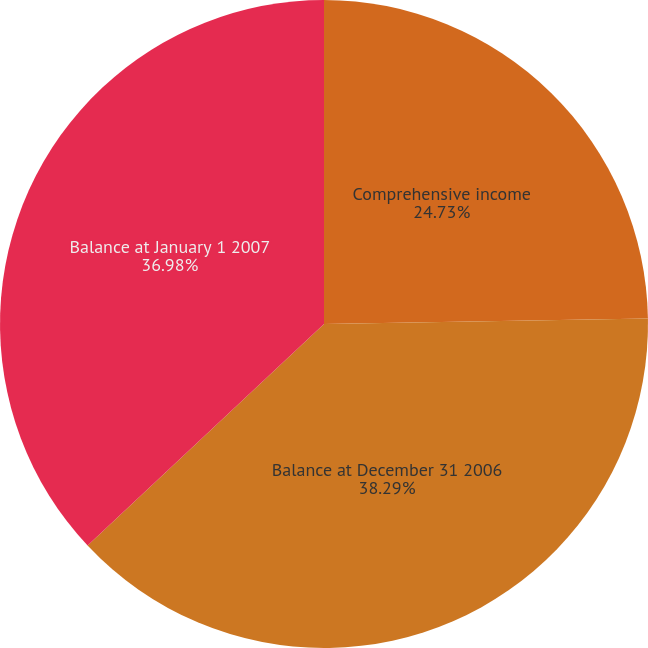Convert chart to OTSL. <chart><loc_0><loc_0><loc_500><loc_500><pie_chart><fcel>Comprehensive income<fcel>Balance at December 31 2006<fcel>Balance at January 1 2007<nl><fcel>24.73%<fcel>38.28%<fcel>36.98%<nl></chart> 